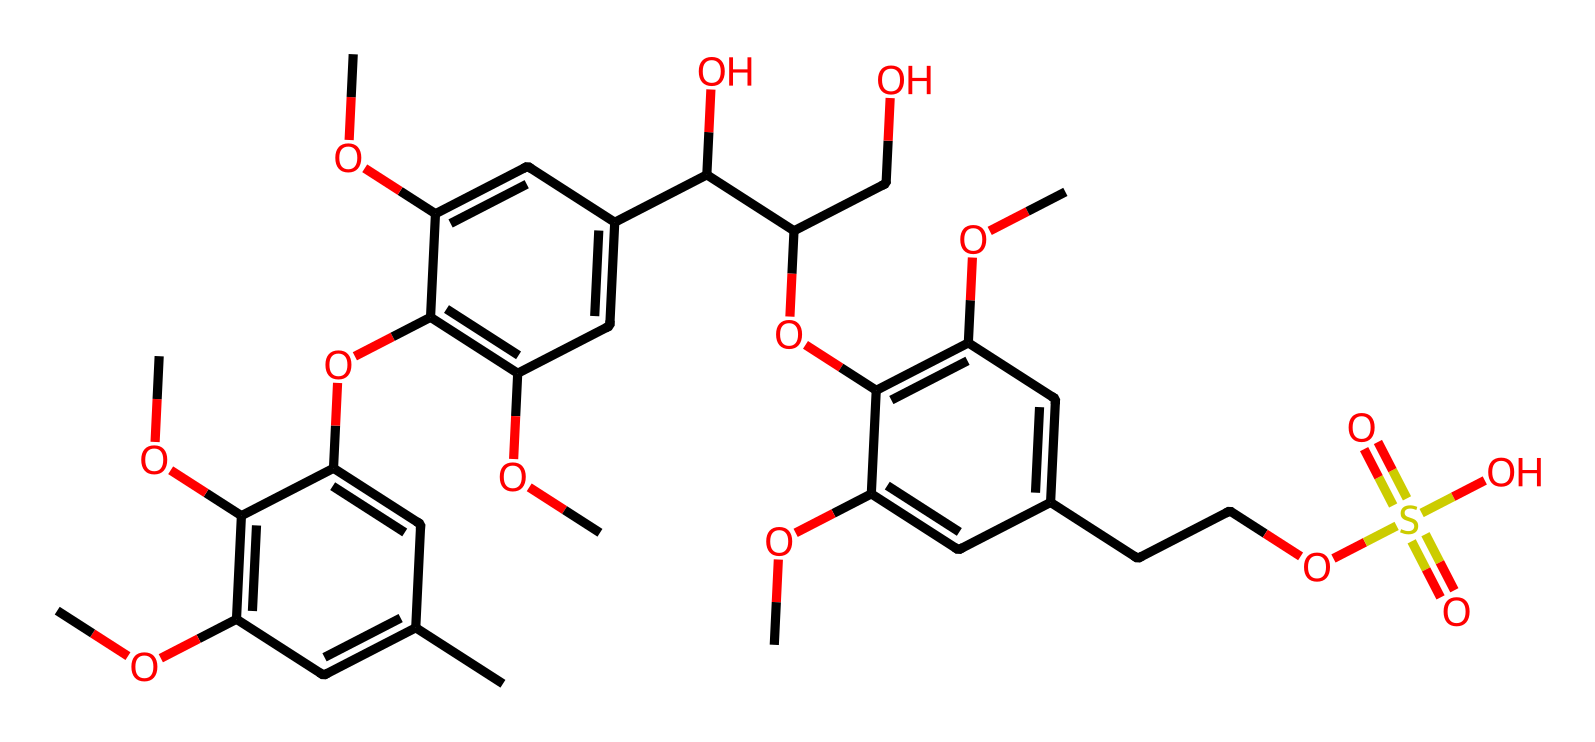What is the primary functional group present in this chemical? The chemical contains multiple ether (-O-) and hydroxyl (-OH) groups, but the prominent feature that stands out is the presence of sugar alcohols derived from glucose, indicating a polyol structure which is characterized by several hydroxyl groups.
Answer: hydroxyl How many carbon atoms are present in the structure? To determine the number of carbon atoms, we can count the 'C' appearances in the SMILES representation. Upon examining the structure, there are 21 carbon atoms in total counted from the representation.
Answer: twenty-one What type of polymer does this chemical represent? This structure is a complex carbohydrate mainly due to its multiple hydroxyl groups and it closely resembles the structure of lignin, which is a phenolic polymer found in woody plants, providing rigidity.
Answer: lignin What is the degree of unsaturation in this molecule? The degree of unsaturation can be calculated by using the formula: Degree of Unsaturation = C + 1 + N/2 - H/2 - X/2. With 21 carbons and 28 hydrogens (counted directly), the degree of unsaturation is calculated to be 9, indicating the presence of rings and/or double bonds in the structure.
Answer: nine What type of bonding is primarily responsible for the structural integrity of this chemical? This chemical has a significant presence of covalent bonds due to its multiple carbon-carbon and carbon-oxygen linkages, which are responsible for the stability and integrity of this lignin polymer structure.
Answer: covalent 